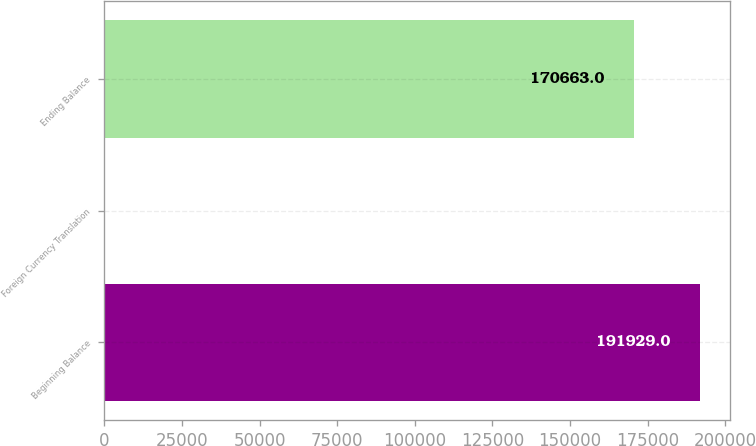Convert chart. <chart><loc_0><loc_0><loc_500><loc_500><bar_chart><fcel>Beginning Balance<fcel>Foreign Currency Translation<fcel>Ending Balance<nl><fcel>191929<fcel>206<fcel>170663<nl></chart> 